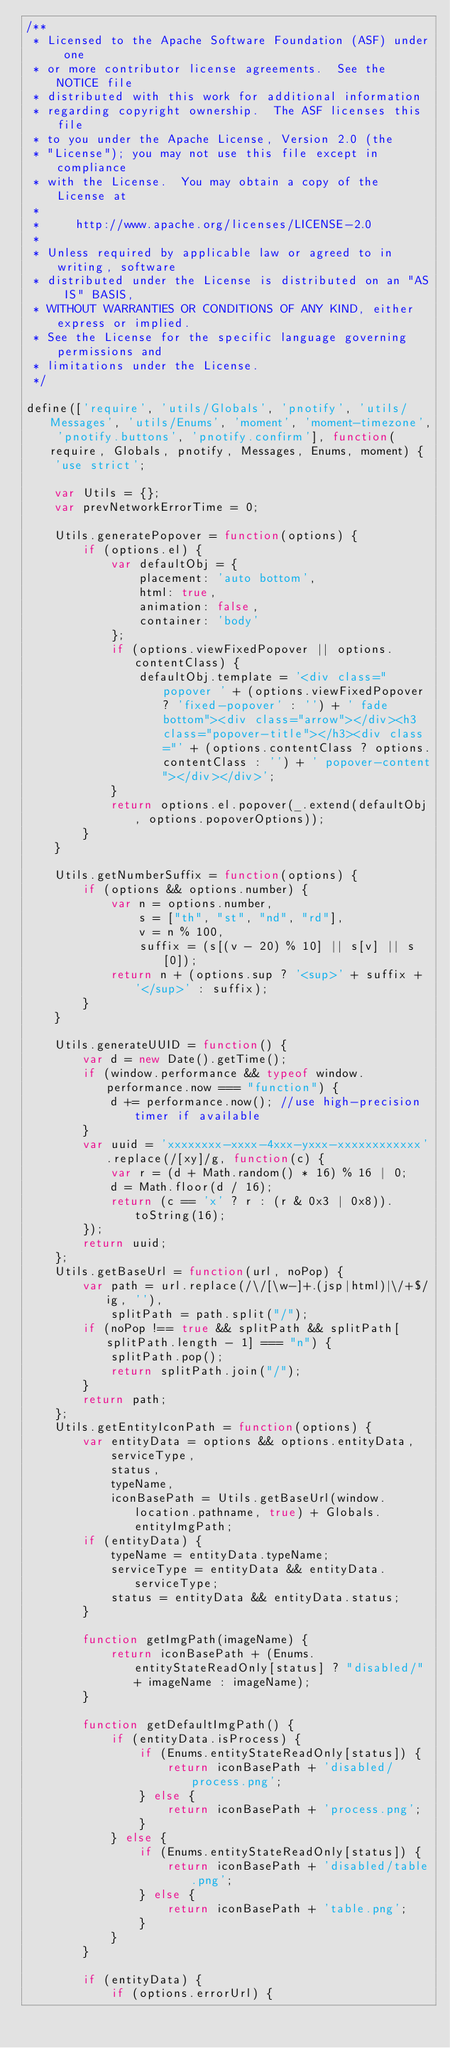<code> <loc_0><loc_0><loc_500><loc_500><_JavaScript_>/**
 * Licensed to the Apache Software Foundation (ASF) under one
 * or more contributor license agreements.  See the NOTICE file
 * distributed with this work for additional information
 * regarding copyright ownership.  The ASF licenses this file
 * to you under the Apache License, Version 2.0 (the
 * "License"); you may not use this file except in compliance
 * with the License.  You may obtain a copy of the License at
 *
 *     http://www.apache.org/licenses/LICENSE-2.0
 *
 * Unless required by applicable law or agreed to in writing, software
 * distributed under the License is distributed on an "AS IS" BASIS,
 * WITHOUT WARRANTIES OR CONDITIONS OF ANY KIND, either express or implied.
 * See the License for the specific language governing permissions and
 * limitations under the License.
 */

define(['require', 'utils/Globals', 'pnotify', 'utils/Messages', 'utils/Enums', 'moment', 'moment-timezone', 'pnotify.buttons', 'pnotify.confirm'], function(require, Globals, pnotify, Messages, Enums, moment) {
    'use strict';

    var Utils = {};
    var prevNetworkErrorTime = 0;

    Utils.generatePopover = function(options) {
        if (options.el) {
            var defaultObj = {
                placement: 'auto bottom',
                html: true,
                animation: false,
                container: 'body'
            };
            if (options.viewFixedPopover || options.contentClass) {
                defaultObj.template = '<div class="popover ' + (options.viewFixedPopover ? 'fixed-popover' : '') + ' fade bottom"><div class="arrow"></div><h3 class="popover-title"></h3><div class="' + (options.contentClass ? options.contentClass : '') + ' popover-content"></div></div>';
            }
            return options.el.popover(_.extend(defaultObj, options.popoverOptions));
        }
    }

    Utils.getNumberSuffix = function(options) {
        if (options && options.number) {
            var n = options.number,
                s = ["th", "st", "nd", "rd"],
                v = n % 100,
                suffix = (s[(v - 20) % 10] || s[v] || s[0]);
            return n + (options.sup ? '<sup>' + suffix + '</sup>' : suffix);
        }
    }

    Utils.generateUUID = function() {
        var d = new Date().getTime();
        if (window.performance && typeof window.performance.now === "function") {
            d += performance.now(); //use high-precision timer if available
        }
        var uuid = 'xxxxxxxx-xxxx-4xxx-yxxx-xxxxxxxxxxxx'.replace(/[xy]/g, function(c) {
            var r = (d + Math.random() * 16) % 16 | 0;
            d = Math.floor(d / 16);
            return (c == 'x' ? r : (r & 0x3 | 0x8)).toString(16);
        });
        return uuid;
    };
    Utils.getBaseUrl = function(url, noPop) {
        var path = url.replace(/\/[\w-]+.(jsp|html)|\/+$/ig, ''),
            splitPath = path.split("/");
        if (noPop !== true && splitPath && splitPath[splitPath.length - 1] === "n") {
            splitPath.pop();
            return splitPath.join("/");
        }
        return path;
    };
    Utils.getEntityIconPath = function(options) {
        var entityData = options && options.entityData,
            serviceType,
            status,
            typeName,
            iconBasePath = Utils.getBaseUrl(window.location.pathname, true) + Globals.entityImgPath;
        if (entityData) {
            typeName = entityData.typeName;
            serviceType = entityData && entityData.serviceType;
            status = entityData && entityData.status;
        }

        function getImgPath(imageName) {
            return iconBasePath + (Enums.entityStateReadOnly[status] ? "disabled/" + imageName : imageName);
        }

        function getDefaultImgPath() {
            if (entityData.isProcess) {
                if (Enums.entityStateReadOnly[status]) {
                    return iconBasePath + 'disabled/process.png';
                } else {
                    return iconBasePath + 'process.png';
                }
            } else {
                if (Enums.entityStateReadOnly[status]) {
                    return iconBasePath + 'disabled/table.png';
                } else {
                    return iconBasePath + 'table.png';
                }
            }
        }

        if (entityData) {
            if (options.errorUrl) {</code> 